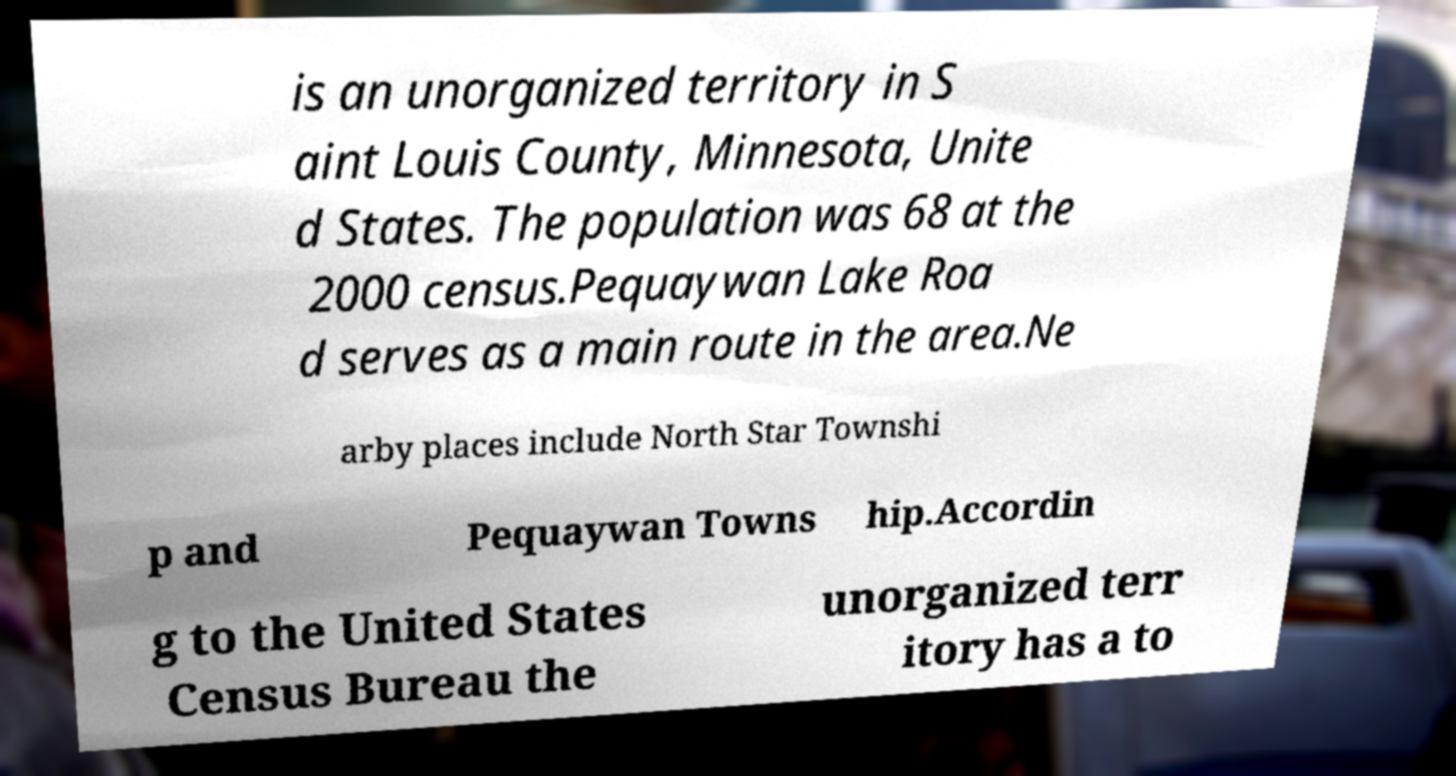Please identify and transcribe the text found in this image. is an unorganized territory in S aint Louis County, Minnesota, Unite d States. The population was 68 at the 2000 census.Pequaywan Lake Roa d serves as a main route in the area.Ne arby places include North Star Townshi p and Pequaywan Towns hip.Accordin g to the United States Census Bureau the unorganized terr itory has a to 